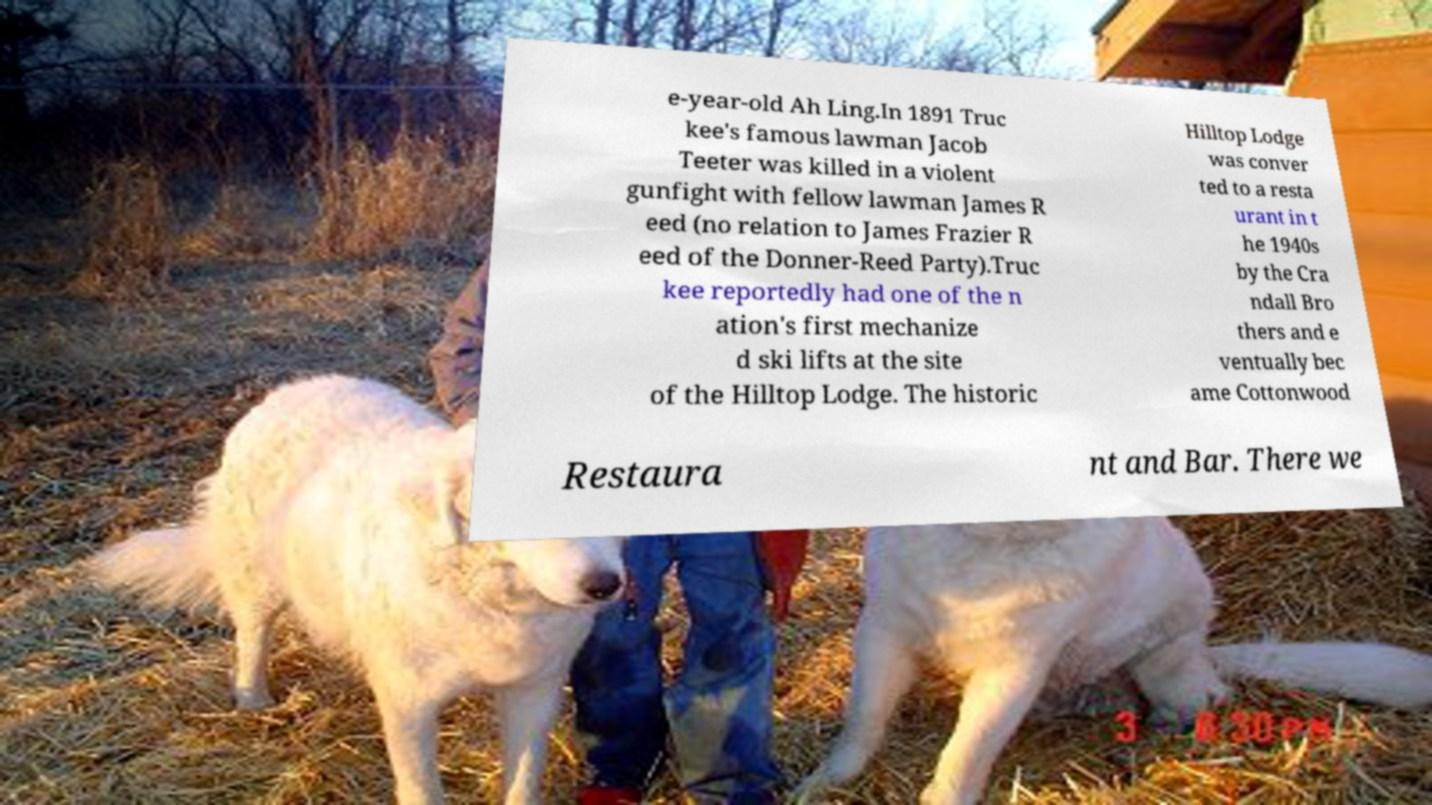For documentation purposes, I need the text within this image transcribed. Could you provide that? e-year-old Ah Ling.In 1891 Truc kee's famous lawman Jacob Teeter was killed in a violent gunfight with fellow lawman James R eed (no relation to James Frazier R eed of the Donner-Reed Party).Truc kee reportedly had one of the n ation's first mechanize d ski lifts at the site of the Hilltop Lodge. The historic Hilltop Lodge was conver ted to a resta urant in t he 1940s by the Cra ndall Bro thers and e ventually bec ame Cottonwood Restaura nt and Bar. There we 